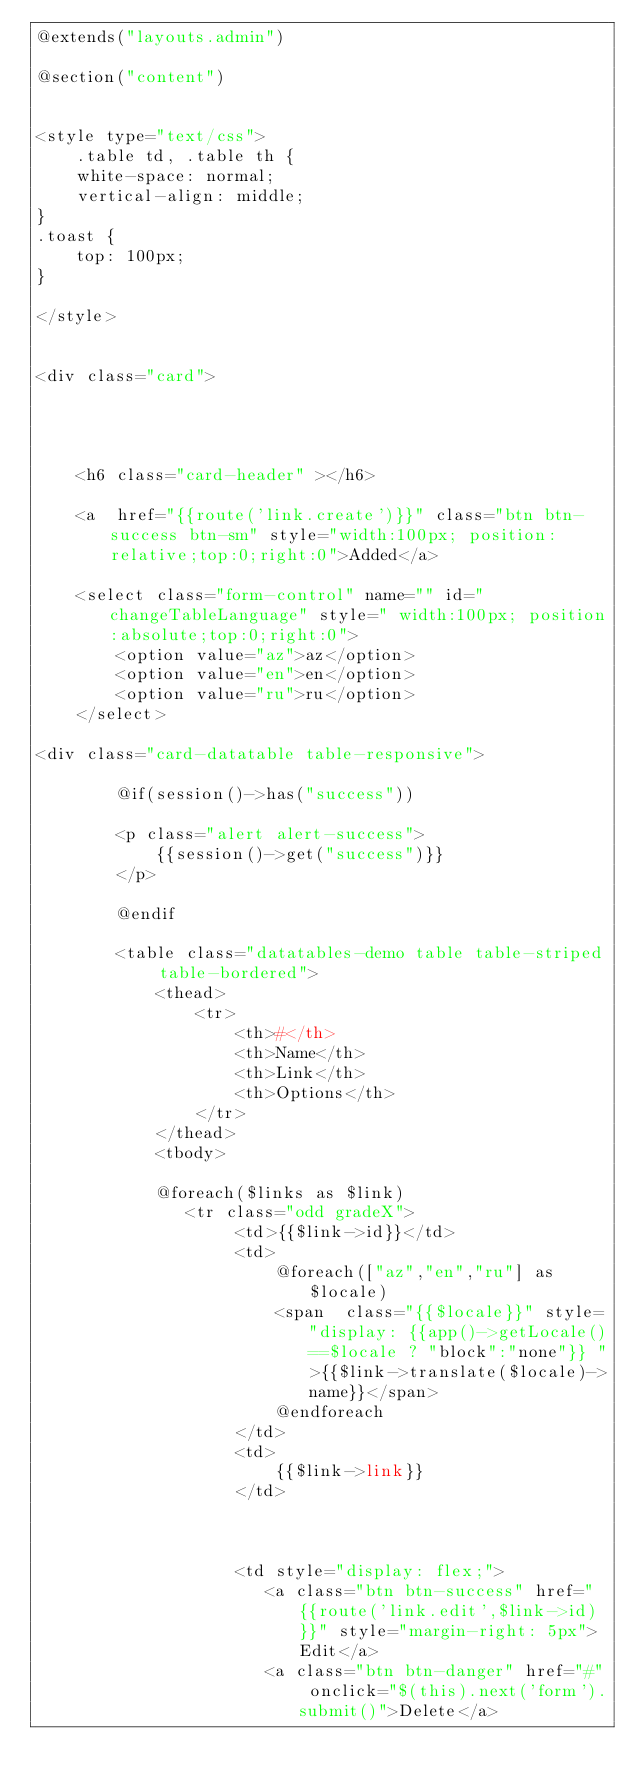Convert code to text. <code><loc_0><loc_0><loc_500><loc_500><_PHP_>@extends("layouts.admin")

@section("content")


<style type="text/css">
    .table td, .table th {
    white-space: normal;
    vertical-align: middle;
}
.toast {
    top: 100px;
}

</style>


<div class="card">




    <h6 class="card-header" ></h6> 

    <a  href="{{route('link.create')}}" class="btn btn-success btn-sm" style="width:100px; position:relative;top:0;right:0">Added</a>

    <select class="form-control" name="" id="changeTableLanguage" style=" width:100px; position:absolute;top:0;right:0">
        <option value="az">az</option>
        <option value="en">en</option>
        <option value="ru">ru</option>
    </select>
  
<div class="card-datatable table-responsive">

        @if(session()->has("success"))

        <p class="alert alert-success">
            {{session()->get("success")}}
        </p>

        @endif

        <table class="datatables-demo table table-striped table-bordered">
            <thead>
                <tr>
                    <th>#</th>
                    <th>Name</th>
                    <th>Link</th>
                    <th>Options</th>
                </tr>
            </thead>
            <tbody>

            @foreach($links as $link)
               <tr class="odd gradeX">
                    <td>{{$link->id}}</td>
                    <td>
                        @foreach(["az","en","ru"] as $locale)
                        <span  class="{{$locale}}" style="display: {{app()->getLocale()==$locale ? "block":"none"}} ">{{$link->translate($locale)->name}}</span>
                        @endforeach
                    </td>
                    <td>
                        {{$link->link}}
                    </td>
                   
                   

                    <td style="display: flex;">
                       <a class="btn btn-success" href="{{route('link.edit',$link->id)}}" style="margin-right: 5px">Edit</a>
                       <a class="btn btn-danger" href="#" onclick="$(this).next('form').submit()">Delete</a>
</code> 